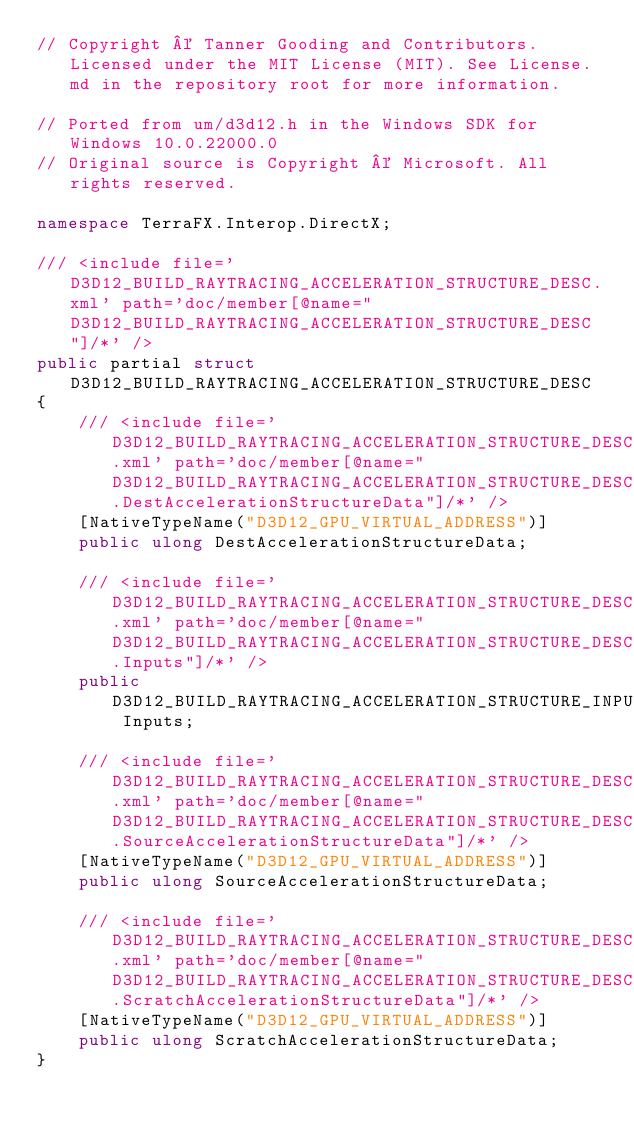Convert code to text. <code><loc_0><loc_0><loc_500><loc_500><_C#_>// Copyright © Tanner Gooding and Contributors. Licensed under the MIT License (MIT). See License.md in the repository root for more information.

// Ported from um/d3d12.h in the Windows SDK for Windows 10.0.22000.0
// Original source is Copyright © Microsoft. All rights reserved.

namespace TerraFX.Interop.DirectX;

/// <include file='D3D12_BUILD_RAYTRACING_ACCELERATION_STRUCTURE_DESC.xml' path='doc/member[@name="D3D12_BUILD_RAYTRACING_ACCELERATION_STRUCTURE_DESC"]/*' />
public partial struct D3D12_BUILD_RAYTRACING_ACCELERATION_STRUCTURE_DESC
{
    /// <include file='D3D12_BUILD_RAYTRACING_ACCELERATION_STRUCTURE_DESC.xml' path='doc/member[@name="D3D12_BUILD_RAYTRACING_ACCELERATION_STRUCTURE_DESC.DestAccelerationStructureData"]/*' />
    [NativeTypeName("D3D12_GPU_VIRTUAL_ADDRESS")]
    public ulong DestAccelerationStructureData;

    /// <include file='D3D12_BUILD_RAYTRACING_ACCELERATION_STRUCTURE_DESC.xml' path='doc/member[@name="D3D12_BUILD_RAYTRACING_ACCELERATION_STRUCTURE_DESC.Inputs"]/*' />
    public D3D12_BUILD_RAYTRACING_ACCELERATION_STRUCTURE_INPUTS Inputs;

    /// <include file='D3D12_BUILD_RAYTRACING_ACCELERATION_STRUCTURE_DESC.xml' path='doc/member[@name="D3D12_BUILD_RAYTRACING_ACCELERATION_STRUCTURE_DESC.SourceAccelerationStructureData"]/*' />
    [NativeTypeName("D3D12_GPU_VIRTUAL_ADDRESS")]
    public ulong SourceAccelerationStructureData;

    /// <include file='D3D12_BUILD_RAYTRACING_ACCELERATION_STRUCTURE_DESC.xml' path='doc/member[@name="D3D12_BUILD_RAYTRACING_ACCELERATION_STRUCTURE_DESC.ScratchAccelerationStructureData"]/*' />
    [NativeTypeName("D3D12_GPU_VIRTUAL_ADDRESS")]
    public ulong ScratchAccelerationStructureData;
}
</code> 